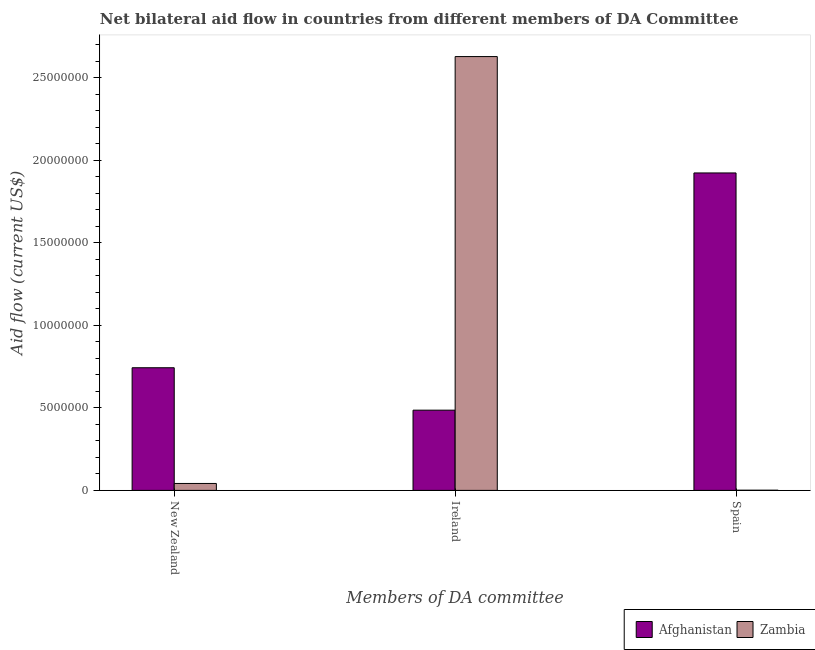How many different coloured bars are there?
Ensure brevity in your answer.  2. How many groups of bars are there?
Give a very brief answer. 3. Are the number of bars per tick equal to the number of legend labels?
Provide a short and direct response. Yes. How many bars are there on the 3rd tick from the right?
Provide a succinct answer. 2. What is the label of the 1st group of bars from the left?
Offer a terse response. New Zealand. What is the amount of aid provided by ireland in Afghanistan?
Make the answer very short. 4.86e+06. Across all countries, what is the maximum amount of aid provided by ireland?
Give a very brief answer. 2.63e+07. Across all countries, what is the minimum amount of aid provided by new zealand?
Offer a terse response. 4.20e+05. In which country was the amount of aid provided by ireland maximum?
Keep it short and to the point. Zambia. In which country was the amount of aid provided by ireland minimum?
Ensure brevity in your answer.  Afghanistan. What is the total amount of aid provided by new zealand in the graph?
Your answer should be compact. 7.85e+06. What is the difference between the amount of aid provided by new zealand in Afghanistan and that in Zambia?
Keep it short and to the point. 7.01e+06. What is the difference between the amount of aid provided by spain in Zambia and the amount of aid provided by ireland in Afghanistan?
Your response must be concise. -4.85e+06. What is the average amount of aid provided by ireland per country?
Ensure brevity in your answer.  1.56e+07. What is the difference between the amount of aid provided by ireland and amount of aid provided by new zealand in Afghanistan?
Your response must be concise. -2.57e+06. In how many countries, is the amount of aid provided by spain greater than 17000000 US$?
Your response must be concise. 1. What is the ratio of the amount of aid provided by ireland in Afghanistan to that in Zambia?
Your answer should be very brief. 0.18. Is the difference between the amount of aid provided by new zealand in Afghanistan and Zambia greater than the difference between the amount of aid provided by spain in Afghanistan and Zambia?
Keep it short and to the point. No. What is the difference between the highest and the second highest amount of aid provided by new zealand?
Offer a terse response. 7.01e+06. What is the difference between the highest and the lowest amount of aid provided by new zealand?
Your response must be concise. 7.01e+06. In how many countries, is the amount of aid provided by new zealand greater than the average amount of aid provided by new zealand taken over all countries?
Provide a short and direct response. 1. What does the 2nd bar from the left in Ireland represents?
Provide a succinct answer. Zambia. What does the 2nd bar from the right in Spain represents?
Give a very brief answer. Afghanistan. Is it the case that in every country, the sum of the amount of aid provided by new zealand and amount of aid provided by ireland is greater than the amount of aid provided by spain?
Provide a succinct answer. No. How many bars are there?
Ensure brevity in your answer.  6. Are all the bars in the graph horizontal?
Offer a very short reply. No. How many countries are there in the graph?
Your response must be concise. 2. What is the difference between two consecutive major ticks on the Y-axis?
Make the answer very short. 5.00e+06. Does the graph contain any zero values?
Your response must be concise. No. Does the graph contain grids?
Your answer should be compact. No. What is the title of the graph?
Your response must be concise. Net bilateral aid flow in countries from different members of DA Committee. Does "Vanuatu" appear as one of the legend labels in the graph?
Your answer should be compact. No. What is the label or title of the X-axis?
Keep it short and to the point. Members of DA committee. What is the Aid flow (current US$) in Afghanistan in New Zealand?
Provide a short and direct response. 7.43e+06. What is the Aid flow (current US$) of Zambia in New Zealand?
Ensure brevity in your answer.  4.20e+05. What is the Aid flow (current US$) in Afghanistan in Ireland?
Provide a short and direct response. 4.86e+06. What is the Aid flow (current US$) in Zambia in Ireland?
Offer a very short reply. 2.63e+07. What is the Aid flow (current US$) in Afghanistan in Spain?
Provide a short and direct response. 1.92e+07. What is the Aid flow (current US$) of Zambia in Spain?
Provide a succinct answer. 10000. Across all Members of DA committee, what is the maximum Aid flow (current US$) in Afghanistan?
Make the answer very short. 1.92e+07. Across all Members of DA committee, what is the maximum Aid flow (current US$) in Zambia?
Make the answer very short. 2.63e+07. Across all Members of DA committee, what is the minimum Aid flow (current US$) of Afghanistan?
Provide a succinct answer. 4.86e+06. Across all Members of DA committee, what is the minimum Aid flow (current US$) in Zambia?
Ensure brevity in your answer.  10000. What is the total Aid flow (current US$) in Afghanistan in the graph?
Offer a terse response. 3.15e+07. What is the total Aid flow (current US$) of Zambia in the graph?
Provide a short and direct response. 2.67e+07. What is the difference between the Aid flow (current US$) of Afghanistan in New Zealand and that in Ireland?
Provide a short and direct response. 2.57e+06. What is the difference between the Aid flow (current US$) of Zambia in New Zealand and that in Ireland?
Offer a terse response. -2.59e+07. What is the difference between the Aid flow (current US$) in Afghanistan in New Zealand and that in Spain?
Keep it short and to the point. -1.18e+07. What is the difference between the Aid flow (current US$) of Afghanistan in Ireland and that in Spain?
Provide a short and direct response. -1.44e+07. What is the difference between the Aid flow (current US$) in Zambia in Ireland and that in Spain?
Provide a short and direct response. 2.63e+07. What is the difference between the Aid flow (current US$) of Afghanistan in New Zealand and the Aid flow (current US$) of Zambia in Ireland?
Give a very brief answer. -1.88e+07. What is the difference between the Aid flow (current US$) in Afghanistan in New Zealand and the Aid flow (current US$) in Zambia in Spain?
Your answer should be compact. 7.42e+06. What is the difference between the Aid flow (current US$) of Afghanistan in Ireland and the Aid flow (current US$) of Zambia in Spain?
Provide a short and direct response. 4.85e+06. What is the average Aid flow (current US$) of Afghanistan per Members of DA committee?
Provide a short and direct response. 1.05e+07. What is the average Aid flow (current US$) in Zambia per Members of DA committee?
Provide a short and direct response. 8.90e+06. What is the difference between the Aid flow (current US$) of Afghanistan and Aid flow (current US$) of Zambia in New Zealand?
Provide a succinct answer. 7.01e+06. What is the difference between the Aid flow (current US$) in Afghanistan and Aid flow (current US$) in Zambia in Ireland?
Keep it short and to the point. -2.14e+07. What is the difference between the Aid flow (current US$) in Afghanistan and Aid flow (current US$) in Zambia in Spain?
Provide a succinct answer. 1.92e+07. What is the ratio of the Aid flow (current US$) in Afghanistan in New Zealand to that in Ireland?
Your answer should be compact. 1.53. What is the ratio of the Aid flow (current US$) in Zambia in New Zealand to that in Ireland?
Offer a terse response. 0.02. What is the ratio of the Aid flow (current US$) of Afghanistan in New Zealand to that in Spain?
Offer a very short reply. 0.39. What is the ratio of the Aid flow (current US$) in Afghanistan in Ireland to that in Spain?
Your response must be concise. 0.25. What is the ratio of the Aid flow (current US$) of Zambia in Ireland to that in Spain?
Provide a succinct answer. 2628. What is the difference between the highest and the second highest Aid flow (current US$) of Afghanistan?
Make the answer very short. 1.18e+07. What is the difference between the highest and the second highest Aid flow (current US$) of Zambia?
Offer a very short reply. 2.59e+07. What is the difference between the highest and the lowest Aid flow (current US$) of Afghanistan?
Your answer should be very brief. 1.44e+07. What is the difference between the highest and the lowest Aid flow (current US$) of Zambia?
Keep it short and to the point. 2.63e+07. 